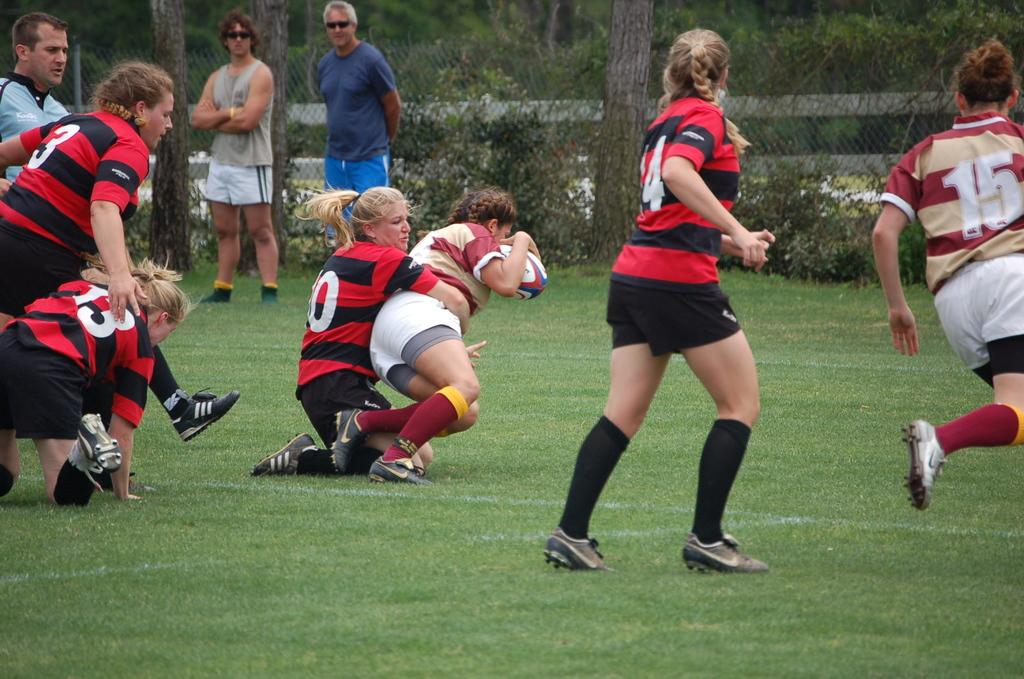How many people are in the image? There is a group of people in the image. What type of ground surface is visible in the image? There is grass in the image. What other types of vegetation can be seen in the image? There are plants and trees in the image. What type of barrier is present in the image? There is a fence in the image. What type of food is being prepared in the image? There is no food preparation visible in the image. What is the fifth element in the image? The provided facts do not mention a fifth element in the image. 